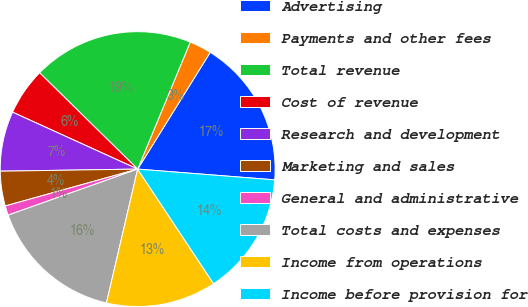Convert chart. <chart><loc_0><loc_0><loc_500><loc_500><pie_chart><fcel>Advertising<fcel>Payments and other fees<fcel>Total revenue<fcel>Cost of revenue<fcel>Research and development<fcel>Marketing and sales<fcel>General and administrative<fcel>Total costs and expenses<fcel>Income from operations<fcel>Income before provision for<nl><fcel>17.4%<fcel>2.6%<fcel>18.89%<fcel>5.56%<fcel>7.04%<fcel>4.08%<fcel>1.11%<fcel>15.92%<fcel>12.96%<fcel>14.44%<nl></chart> 